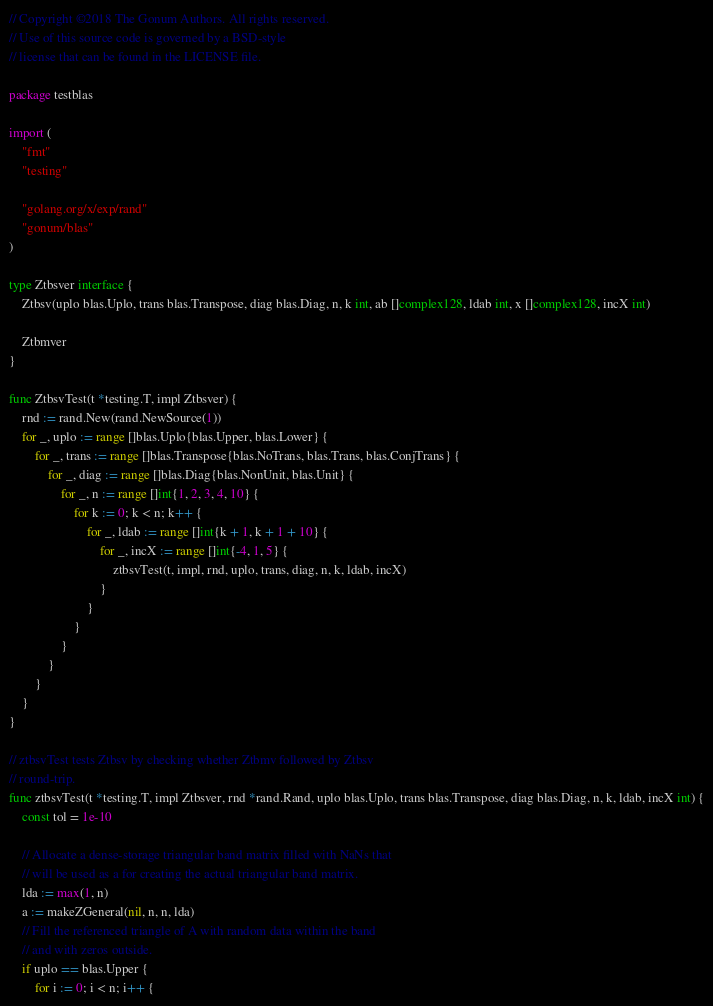Convert code to text. <code><loc_0><loc_0><loc_500><loc_500><_Go_>// Copyright ©2018 The Gonum Authors. All rights reserved.
// Use of this source code is governed by a BSD-style
// license that can be found in the LICENSE file.

package testblas

import (
	"fmt"
	"testing"

	"golang.org/x/exp/rand"
	"gonum/blas"
)

type Ztbsver interface {
	Ztbsv(uplo blas.Uplo, trans blas.Transpose, diag blas.Diag, n, k int, ab []complex128, ldab int, x []complex128, incX int)

	Ztbmver
}

func ZtbsvTest(t *testing.T, impl Ztbsver) {
	rnd := rand.New(rand.NewSource(1))
	for _, uplo := range []blas.Uplo{blas.Upper, blas.Lower} {
		for _, trans := range []blas.Transpose{blas.NoTrans, blas.Trans, blas.ConjTrans} {
			for _, diag := range []blas.Diag{blas.NonUnit, blas.Unit} {
				for _, n := range []int{1, 2, 3, 4, 10} {
					for k := 0; k < n; k++ {
						for _, ldab := range []int{k + 1, k + 1 + 10} {
							for _, incX := range []int{-4, 1, 5} {
								ztbsvTest(t, impl, rnd, uplo, trans, diag, n, k, ldab, incX)
							}
						}
					}
				}
			}
		}
	}
}

// ztbsvTest tests Ztbsv by checking whether Ztbmv followed by Ztbsv
// round-trip.
func ztbsvTest(t *testing.T, impl Ztbsver, rnd *rand.Rand, uplo blas.Uplo, trans blas.Transpose, diag blas.Diag, n, k, ldab, incX int) {
	const tol = 1e-10

	// Allocate a dense-storage triangular band matrix filled with NaNs that
	// will be used as a for creating the actual triangular band matrix.
	lda := max(1, n)
	a := makeZGeneral(nil, n, n, lda)
	// Fill the referenced triangle of A with random data within the band
	// and with zeros outside.
	if uplo == blas.Upper {
		for i := 0; i < n; i++ {</code> 